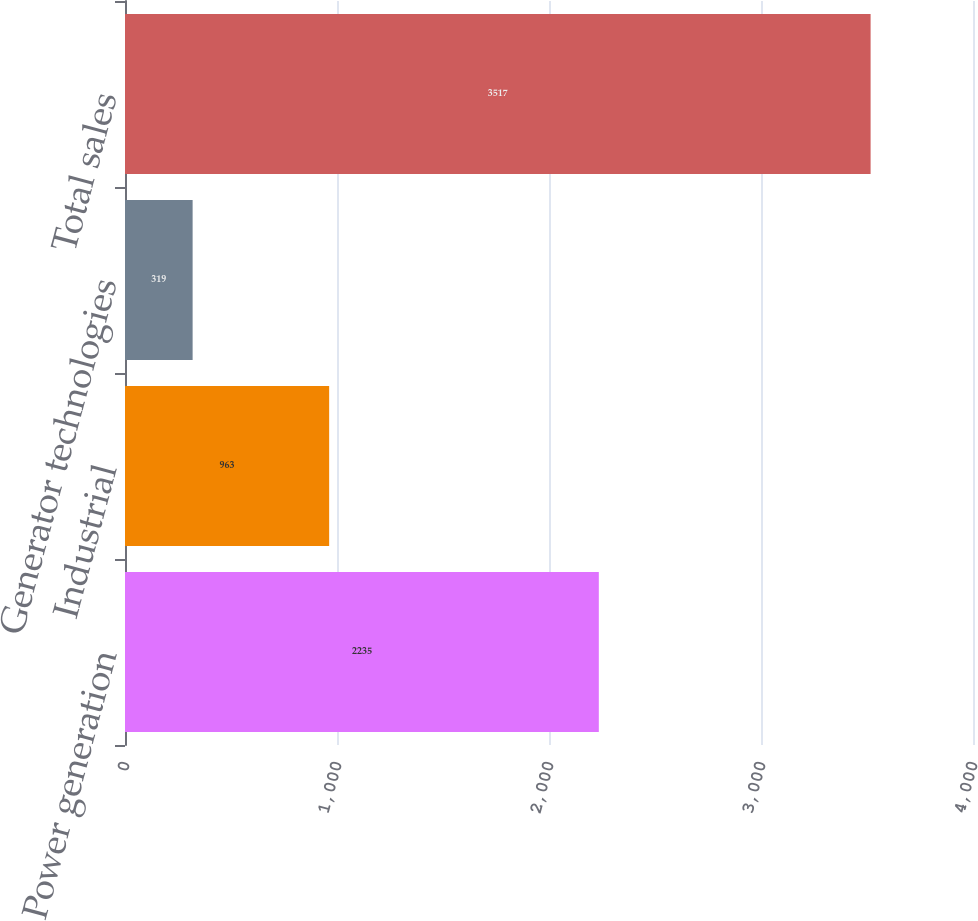Convert chart. <chart><loc_0><loc_0><loc_500><loc_500><bar_chart><fcel>Power generation<fcel>Industrial<fcel>Generator technologies<fcel>Total sales<nl><fcel>2235<fcel>963<fcel>319<fcel>3517<nl></chart> 